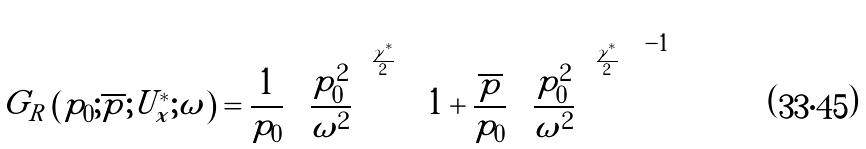Convert formula to latex. <formula><loc_0><loc_0><loc_500><loc_500>G _ { R } \left ( p _ { 0 } ; \overline { p } ; U _ { x } ^ { * } ; \omega \right ) = \frac { 1 } { p _ { 0 } } \left ( \frac { p ^ { 2 } _ { 0 } } { \omega ^ { 2 } } \right ) ^ { \frac { \gamma ^ { * } } { 2 } } \left [ 1 + \frac { \overline { p } } { p _ { 0 } } \left ( \frac { p _ { 0 } ^ { 2 } } { \omega ^ { 2 } } \right ) ^ { \frac { \gamma ^ { * } } { 2 } } \right ] ^ { - 1 }</formula> 